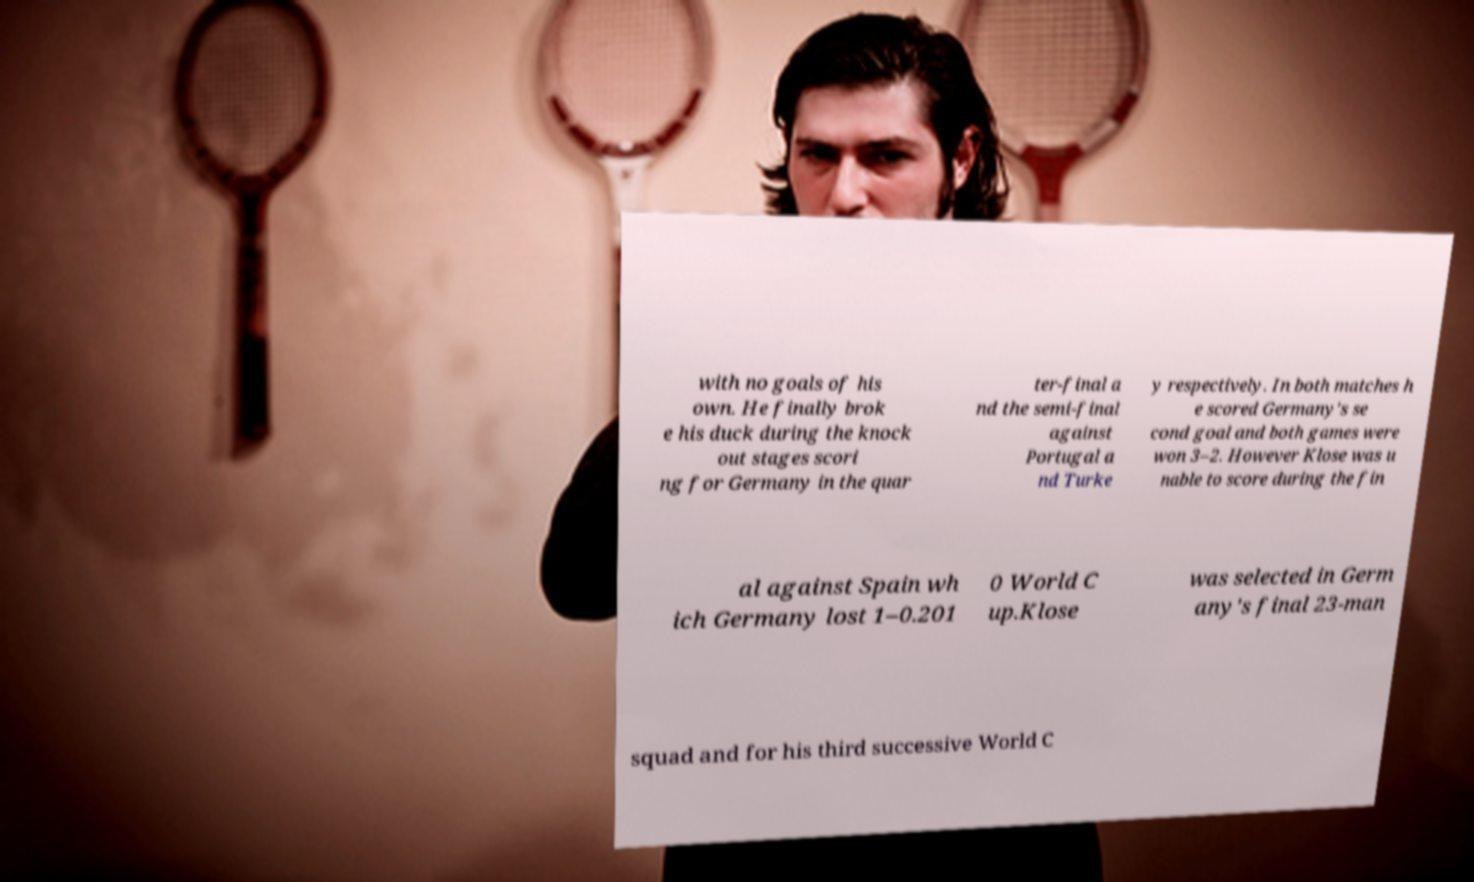Can you accurately transcribe the text from the provided image for me? with no goals of his own. He finally brok e his duck during the knock out stages scori ng for Germany in the quar ter-final a nd the semi-final against Portugal a nd Turke y respectively. In both matches h e scored Germany's se cond goal and both games were won 3–2. However Klose was u nable to score during the fin al against Spain wh ich Germany lost 1–0.201 0 World C up.Klose was selected in Germ any's final 23-man squad and for his third successive World C 